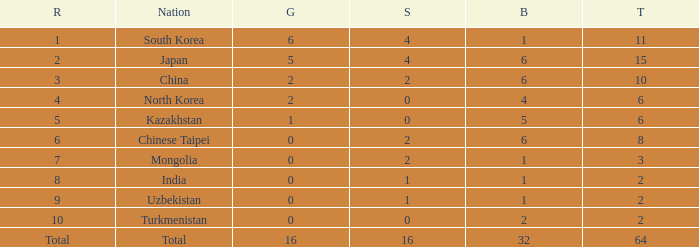What's the biggest Bronze that has less than 0 Silvers? None. 